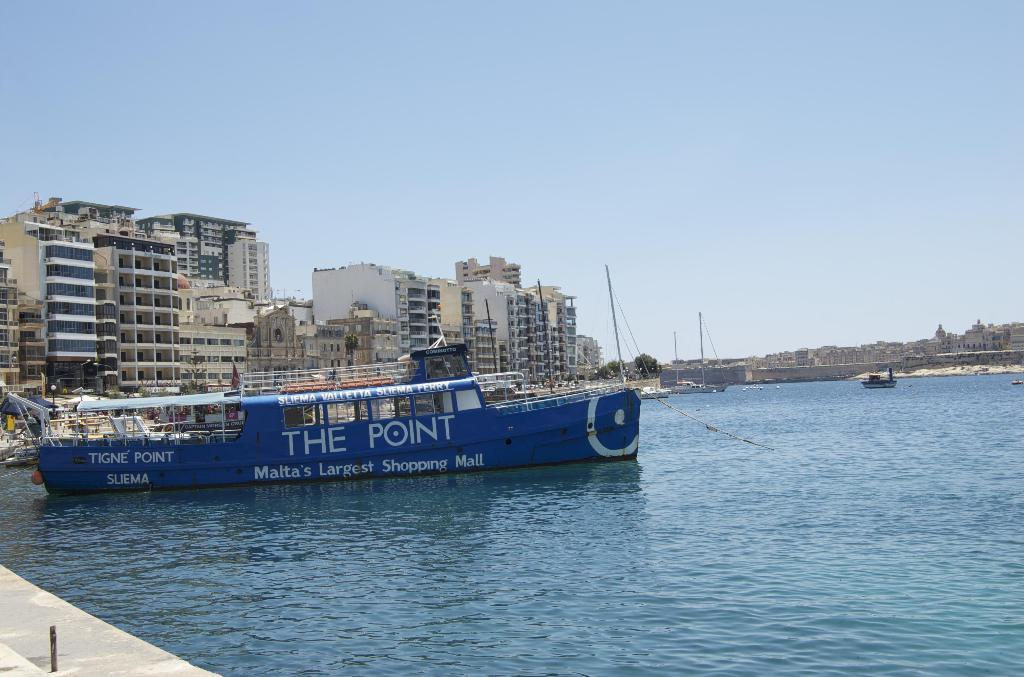<image>
Render a clear and concise summary of the photo. A blue ship advertises Malta's largest shopping mall. 